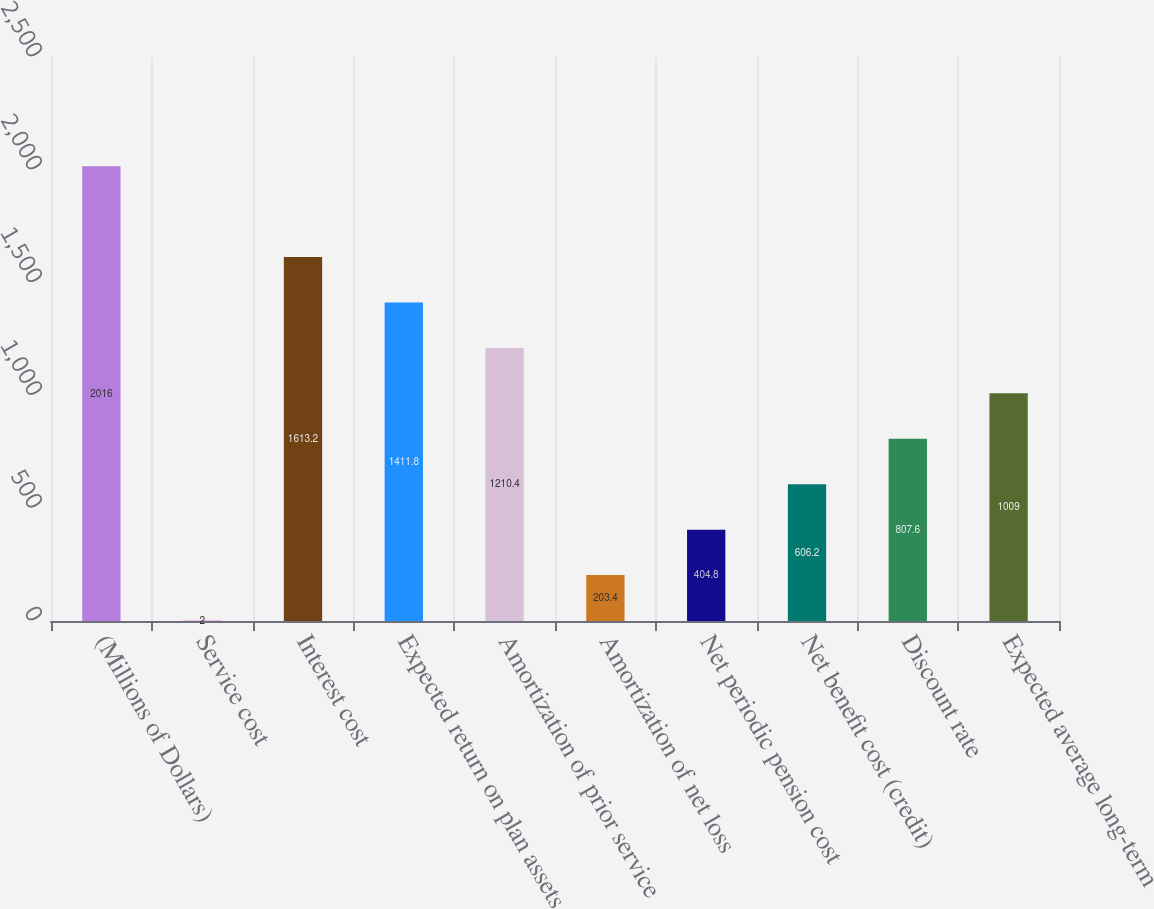Convert chart. <chart><loc_0><loc_0><loc_500><loc_500><bar_chart><fcel>(Millions of Dollars)<fcel>Service cost<fcel>Interest cost<fcel>Expected return on plan assets<fcel>Amortization of prior service<fcel>Amortization of net loss<fcel>Net periodic pension cost<fcel>Net benefit cost (credit)<fcel>Discount rate<fcel>Expected average long-term<nl><fcel>2016<fcel>2<fcel>1613.2<fcel>1411.8<fcel>1210.4<fcel>203.4<fcel>404.8<fcel>606.2<fcel>807.6<fcel>1009<nl></chart> 